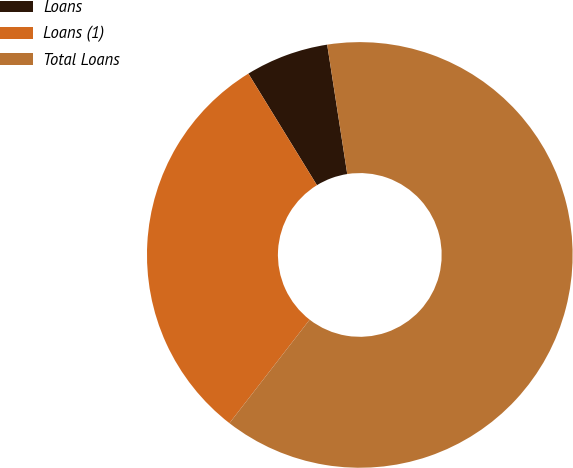<chart> <loc_0><loc_0><loc_500><loc_500><pie_chart><fcel>Loans<fcel>Loans (1)<fcel>Total Loans<nl><fcel>6.32%<fcel>30.74%<fcel>62.94%<nl></chart> 